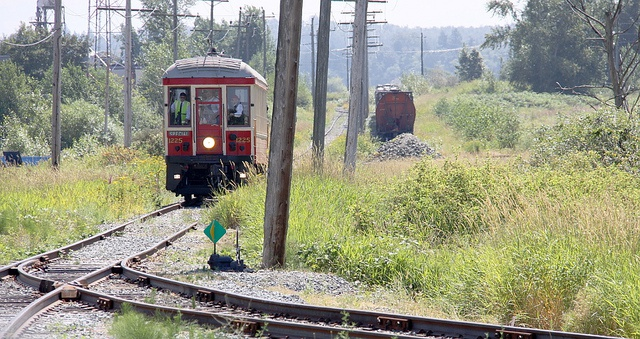Describe the objects in this image and their specific colors. I can see train in lavender, black, gray, maroon, and darkgray tones, train in lavender, purple, navy, darkgray, and lightgray tones, people in lavender, gray, black, and green tones, and people in lavender, black, and gray tones in this image. 